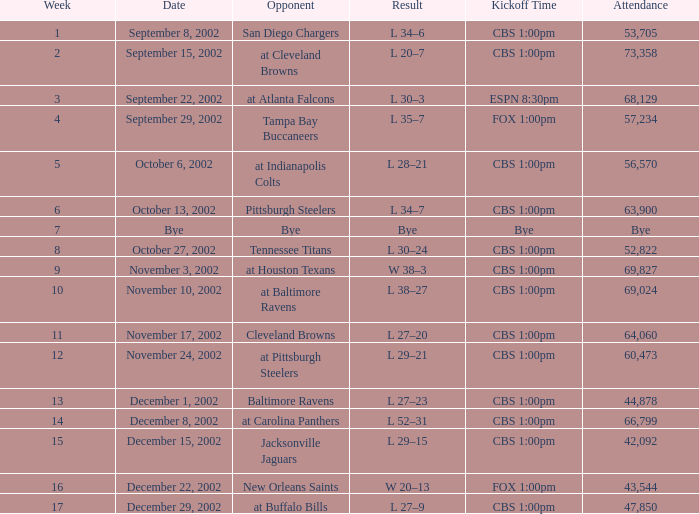What time does the game commence in the 17th week? CBS 1:00pm. 